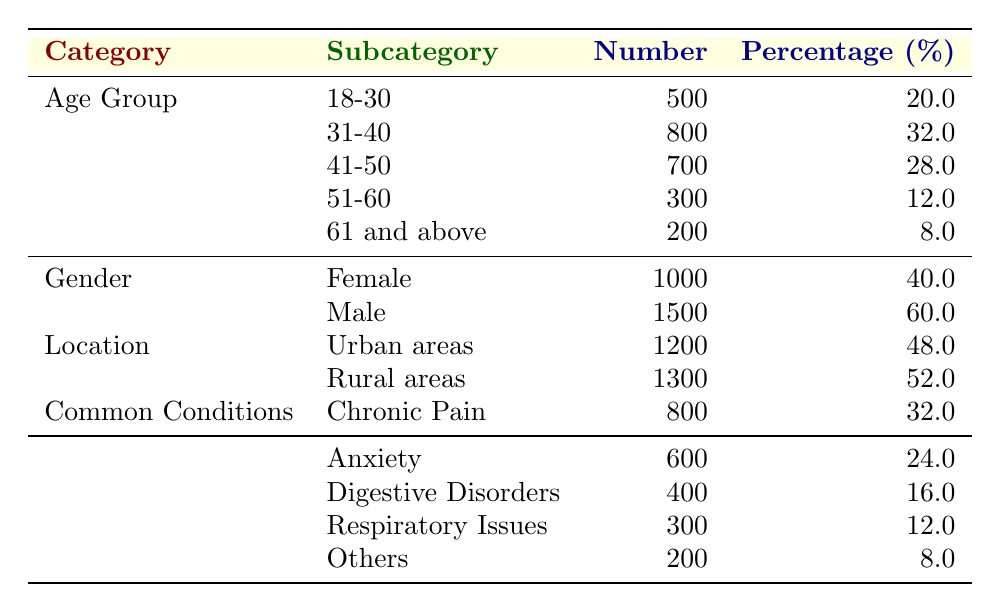What is the total number of patients in the age group 41-50? The table states that there are 700 patients in the age group 41-50. Therefore, the total number of patients in this category is directly given as 700.
Answer: 700 What is the percentage of male patients? According to the table, there are 1500 male patients out of a total of 2500 patients (1000 female + 1500 male). The percentage of male patients is calculated as (1500/2500) * 100 = 60%.
Answer: 60.0% What is the common condition treated that has the lowest number of patients? Reviewing the "Common Conditions" section, the condition "Others" has the lowest count of patients, with only 200. This can be concluded by comparing all the numbers listed under common conditions.
Answer: Others How many patients are located in rural areas compared to urban areas? The number of patients in rural areas is 1300, while in urban areas, it is 1200. The difference between rural and urban areas is 1300 - 1200 = 100, indicating there are more patients in rural areas by 100 patients.
Answer: 100 Is it true that the majority of patients are females? The table shows that there are 1000 female patients (40%) and 1500 male patients (60%). Since 1500 males is greater than 1000 females, it is false to state that the majority are females.
Answer: No What age group has the highest number of patients? Looking at the “Age Group” section, the group 31-40 has the highest number of patients at 800, which is more than any other age group. This can be determined by comparing all the numerical values in the age groups.
Answer: 31-40 What is the total number of patients treated for chronic pain and anxiety combined? The number of patients treated for chronic pain is 800 and those treated for anxiety is 600. Adding these two together gives 800 + 600 = 1400, indicating the total number of patients treated for these conditions.
Answer: 1400 What percentage of patients are aged 60 and above? The age groups 51-60 and 61 and above account for 300 (51-60) + 200 (61 and above) = 500 patients. To find the percentage, we take (500/2500) * 100, resulting in 20%.
Answer: 20.0% 